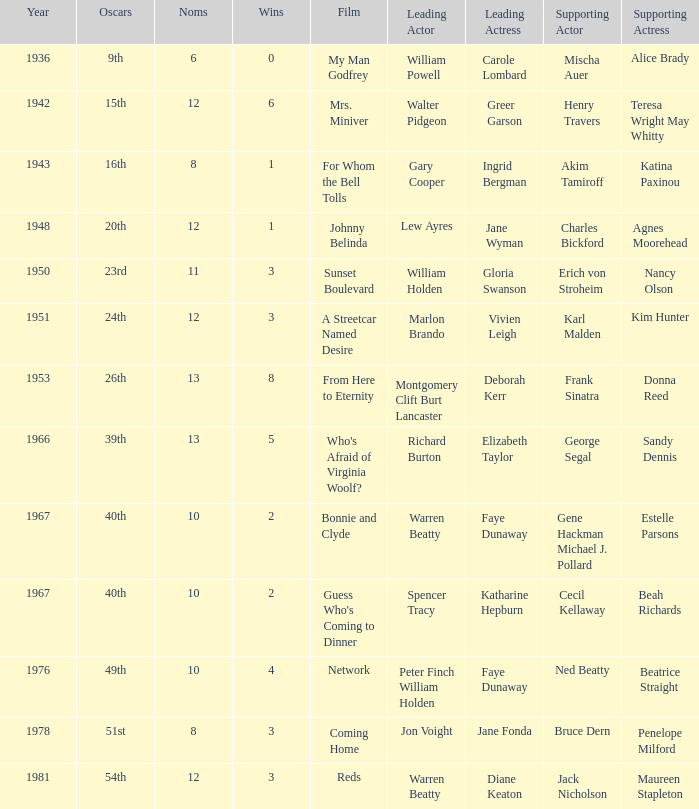Who was the supporting actress in 1943? Katina Paxinou. 